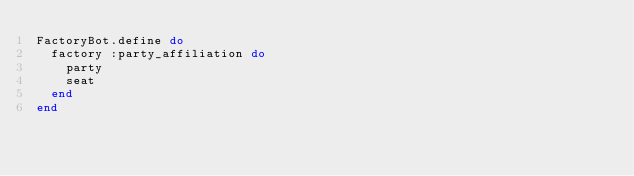Convert code to text. <code><loc_0><loc_0><loc_500><loc_500><_Ruby_>FactoryBot.define do
  factory :party_affiliation do
    party
    seat
  end
end
</code> 